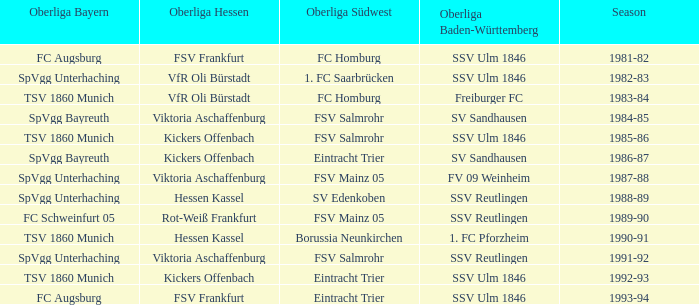Which oberliga südwes has an oberliga baden-württemberg of sv sandhausen in 1984-85? FSV Salmrohr. 